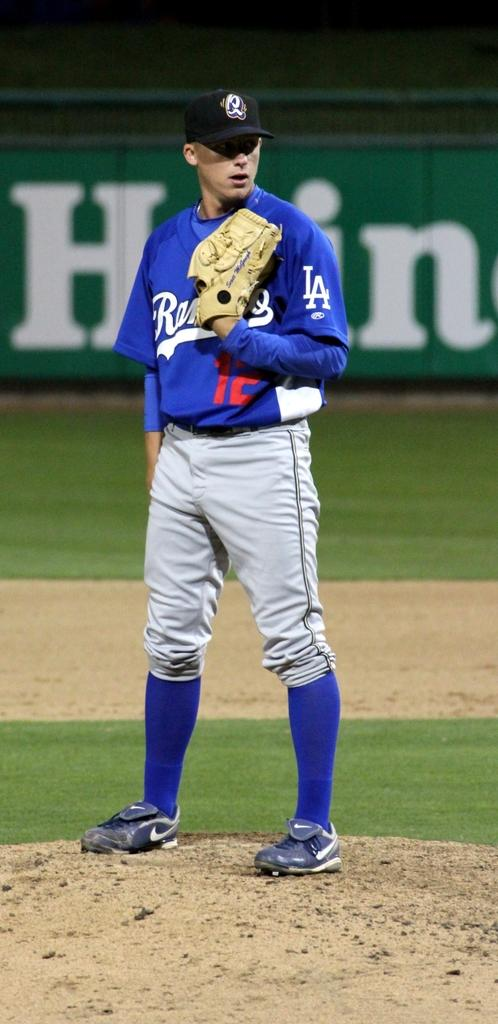Who is present in the image? There is a man in the image. What is the man wearing on his hands? The man is wearing gloves. In which direction is the man looking? The man is looking to the right side of the image. What can be seen in the distance? There is a hoarding in the distance. What type of suit is the man wearing in the image? The provided facts do not mention a suit; the man is wearing gloves. 